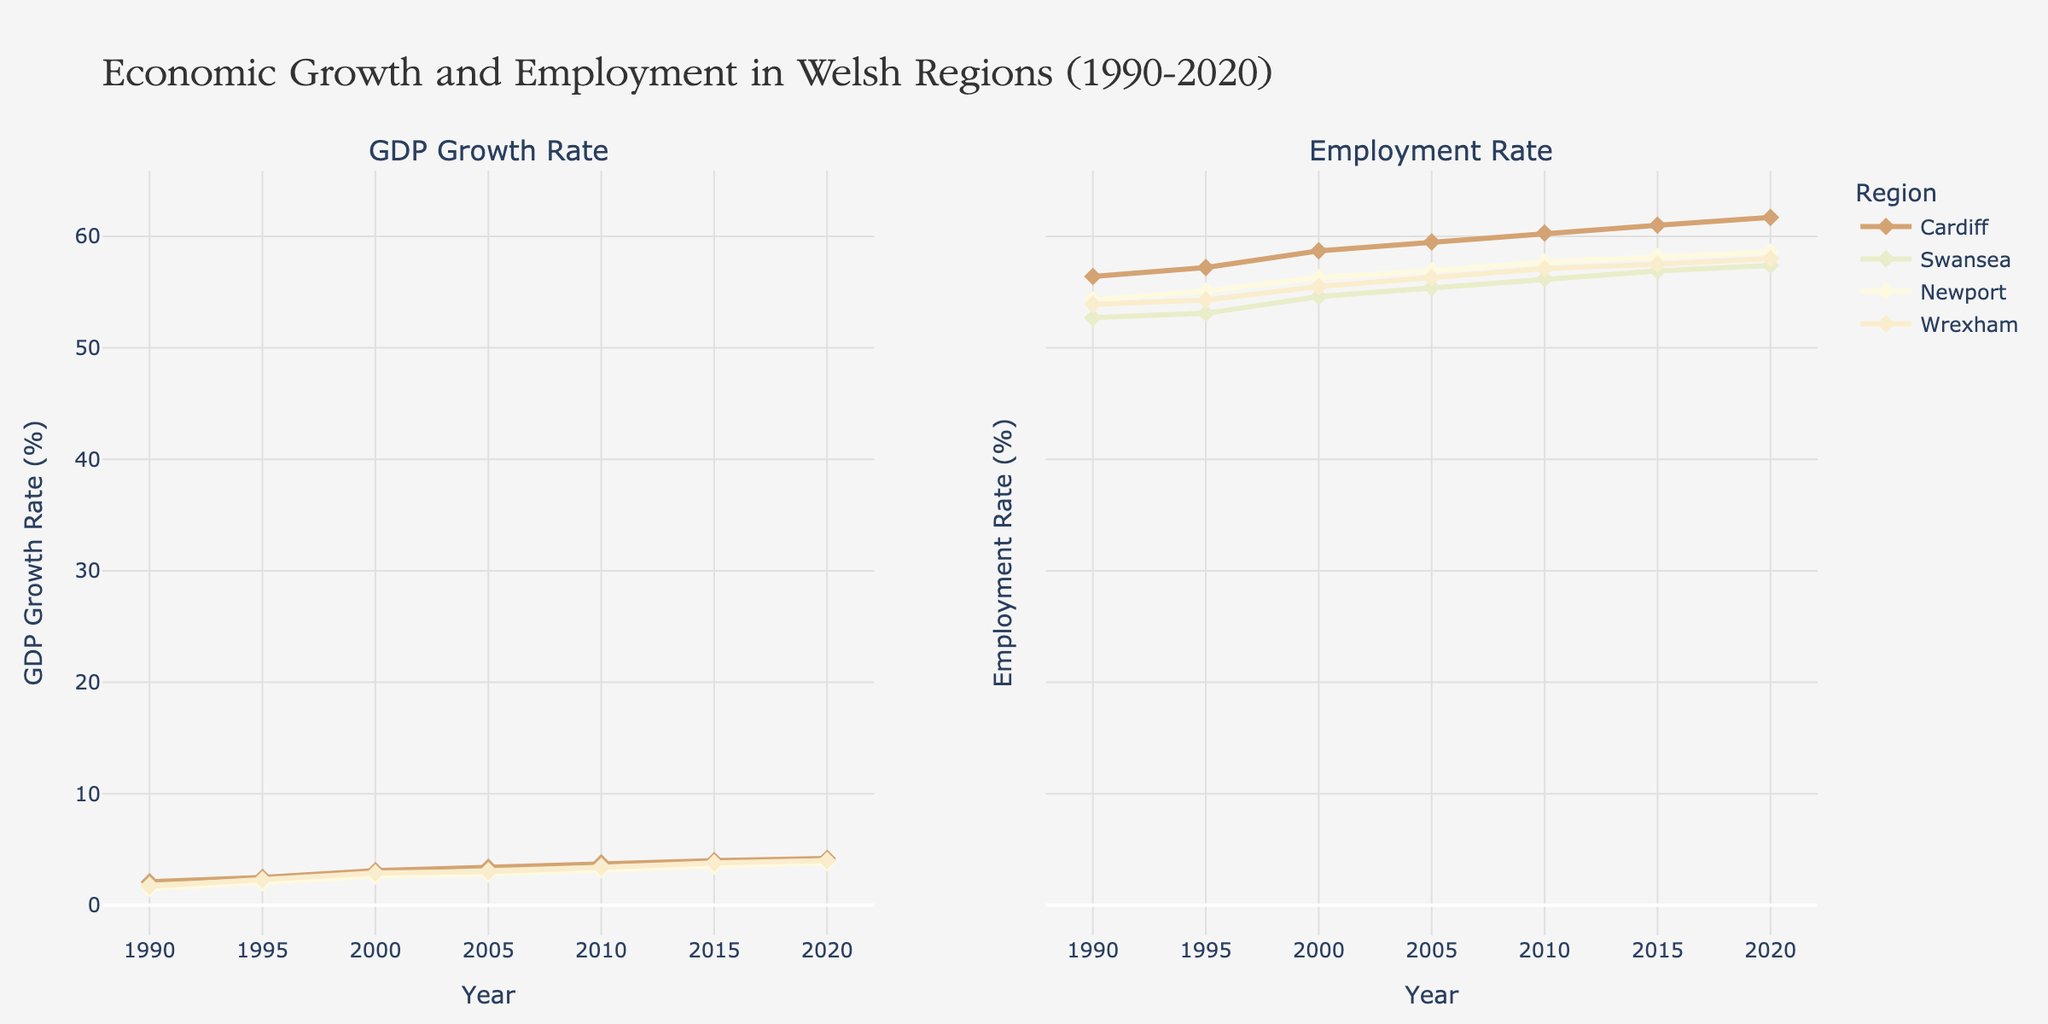What is the overall title of the figure? The title is usually located at the top of the figure. In this case, it reads "Economic Growth and Employment in Welsh Regions (1990-2020)."
Answer: Economic Growth and Employment in Welsh Regions (1990-2020) How many subplots are there in the figure, and what are they titled? The figure contains two subplots, which can be identified by their distinct titles. The first subplot is titled "GDP Growth Rate," and the second is titled "Employment Rate."
Answer: Two: "GDP Growth Rate" and "Employment Rate" Which region had the highest GDP Growth Rate in 2020? By examining the "GDP Growth Rate" subplot for the year 2020, we can see that Cardiff has the highest GDP Growth Rate at 4.2%.
Answer: Cardiff What is the employment rate in Swansea in 2015? In the "Employment Rate" subplot, look for the data point corresponding to Swansea in the year 2015. The employment rate is 56.9%.
Answer: 56.9% Which region shows the most significant improvement in employment rate from 1990 to 2020? To find the region with the most significant improvement, calculate the difference in employment rates between 1990 and 2020 for each region. Cardiff improves from 56.4% to 61.7%, which is an increase of 5.3 percentage points. This is the highest among the regions.
Answer: Cardiff Between 2000 and 2005, which region had the smallest increase in GDP Growth Rate? Compare the GDP Growth Rates for all regions between 2000 and 2005. Newport had a GDP Growth Rate of 2.6% in 2000 and 2.8% in 2005, an increase of 0.2 percentage points, which is the smallest among the regions.
Answer: Newport How did the GDP Growth Rate of Wrexham in 1995 compare to the employment rate in Wrexham in the same year? By comparing the two subplots for the year 1995, we find that Wrexham's GDP Growth Rate was 2.3% while its employment rate was 54.3%.
Answer: 2.3% for GDP Growth Rate and 54.3% for Employment Rate Which region consistently had the lowest employment rates throughout the period 1990-2020? To identify this, look at the "Employment Rate" subplot and check the employment rates for all years across regions. Swansea consistently shows the lowest employment rates over the period.
Answer: Swansea In which year did Cardiff surpass a GDP Growth Rate of 4%? By observing the "GDP Growth Rate" subplot for Cardiff, it can be seen that Cardiff surpassed a 4% GDP Growth Rate in 2015.
Answer: 2015 Which subplot would you look at to analyze trends in employment across different regions? To analyze trends in employment, you would look at the "Employment Rate" subplot, as it specifically displays employment rate data across the regions and years.
Answer: Employment Rate 